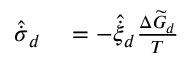Convert formula to latex. <formula><loc_0><loc_0><loc_500><loc_500>\begin{array} { r l } { \hat { \dot { \sigma } } _ { d } } & = - { \hat { \dot { \xi } } _ { d } } \frac { \Delta \widetilde { G } _ { d } } { T } } \end{array}</formula> 